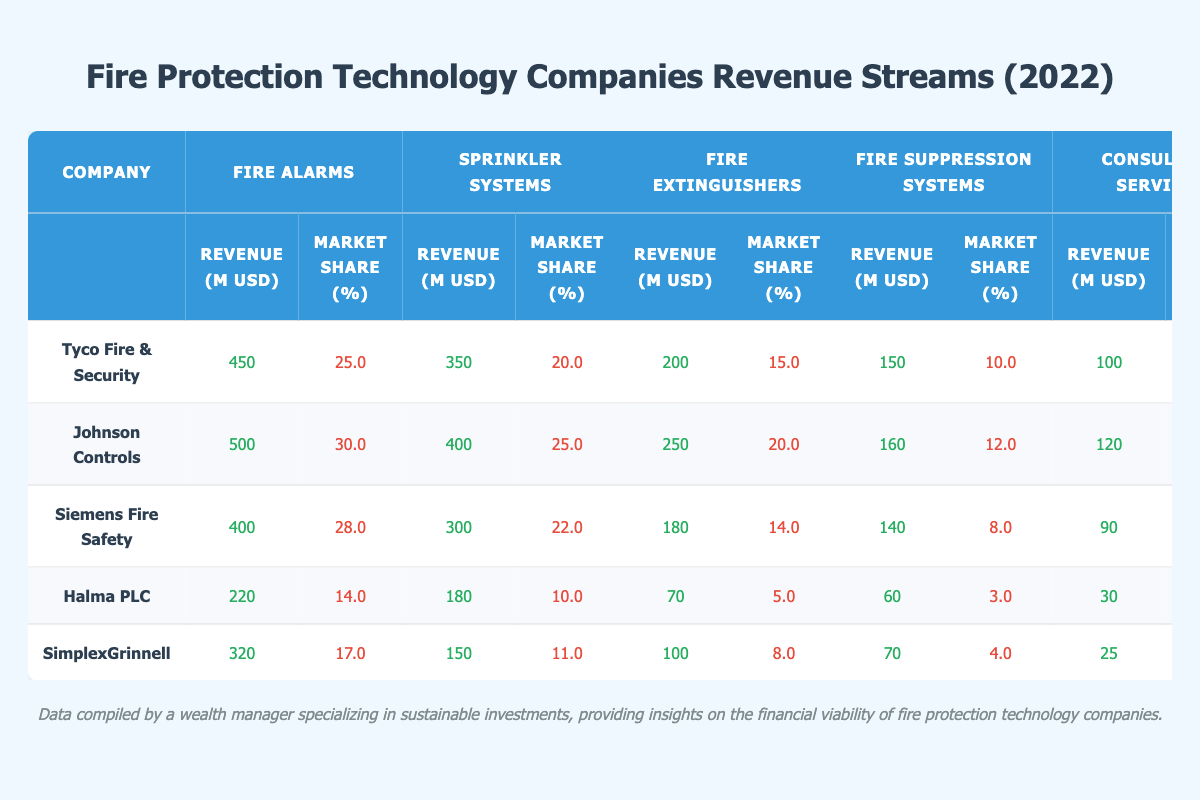What is the total revenue from fire alarms across all companies? To find the total revenue from fire alarms, I will sum the revenue of fire alarms from each company: 450 + 500 + 400 + 220 + 320 = 1890 million USD.
Answer: 1890 million USD Which company has the highest market share for sprinkler systems? By looking at the market share percentages for sprinkler systems: Tyco (20.0%), Johnson Controls (25.0%), Siemens (22.0%), Halma (10.0%), and SimplexGrinnell (11.0%), Johnson Controls has the highest market share at 25.0%.
Answer: Johnson Controls What is the average revenue from fire suppression systems for the companies listed? To calculate the average revenue from fire suppression systems, I will add the revenues: 150 + 160 + 140 + 60 + 70 = 580 million USD, then divide by the number of companies (5): 580 / 5 = 116 million USD.
Answer: 116 million USD Did any company achieve a market share of over 15% for fire extinguishers? I will check the market share for fire extinguishers for each company: Tyco (15.0%), Johnson Controls (20.0%), Siemens (14.0%), Halma (5.0%), and SimplexGrinnell (8.0%). Johnson Controls is the only company with over 15%, at 20.0%.
Answer: Yes What is the total revenue from consulting services for the three companies with the highest overall revenue? The three companies with the highest overall revenue are Johnson Controls (500 + 400 + 250 + 160 + 120 = 1430 million USD), Tyco Fire & Security (450 + 350 + 200 + 150 + 100 = 1250 million USD), and Siemens Fire Safety (400 + 300 + 180 + 140 + 90 = 1110 million USD). Their consulting service revenues are 120 (Johnson Controls) + 100 (Tyco) + 90 (Siemens) = 310 million USD total.
Answer: 310 million USD How much revenue did Halma PLC generate from fire alarms? Referring to Halma PLC's row in the table, I see that the revenue from fire alarms is listed as 220 million USD.
Answer: 220 million USD What percentage of the total fire extinguishers revenue does Johnson Controls contribute? To find Johnson Controls' contribution to the total fire extinguishers revenue, I will first sum the fire extinguishers revenue: 200 + 250 + 180 + 70 + 100 = 800 million USD, then calculate Johnson Controls' contribution: 250 / 800 * 100 = 31.25%.
Answer: 31.25% Which product line generates the lowest revenue for Tyco Fire & Security? Looking at Tyco Fire & Security's revenue by product line, fire suppression systems generate 150 million USD, which is the lowest compared to fire alarms (450), sprinkler systems (350), fire extinguishers (200), and consulting services (100).
Answer: Consulting services What is the combined market share of Siemens Fire Safety in both fire alarms and fire extinguishers? Siemens Fire Safety has market shares of 28.0% for fire alarms and 14.0% for fire extinguishers. Therefore, to find the combined market share, I add these two values: 28.0 + 14.0 = 42.0%.
Answer: 42.0% Which company has the second highest revenue from sprinkler systems? The sprinkler system revenues are: Tyco (350 million USD), Johnson Controls (400 million USD), Siemens (300 million USD), Halma (180 million USD), and SimplexGrinnell (150 million USD). Thus, Tyco has the second highest revenue at 350 million USD.
Answer: Tyco Fire & Security 